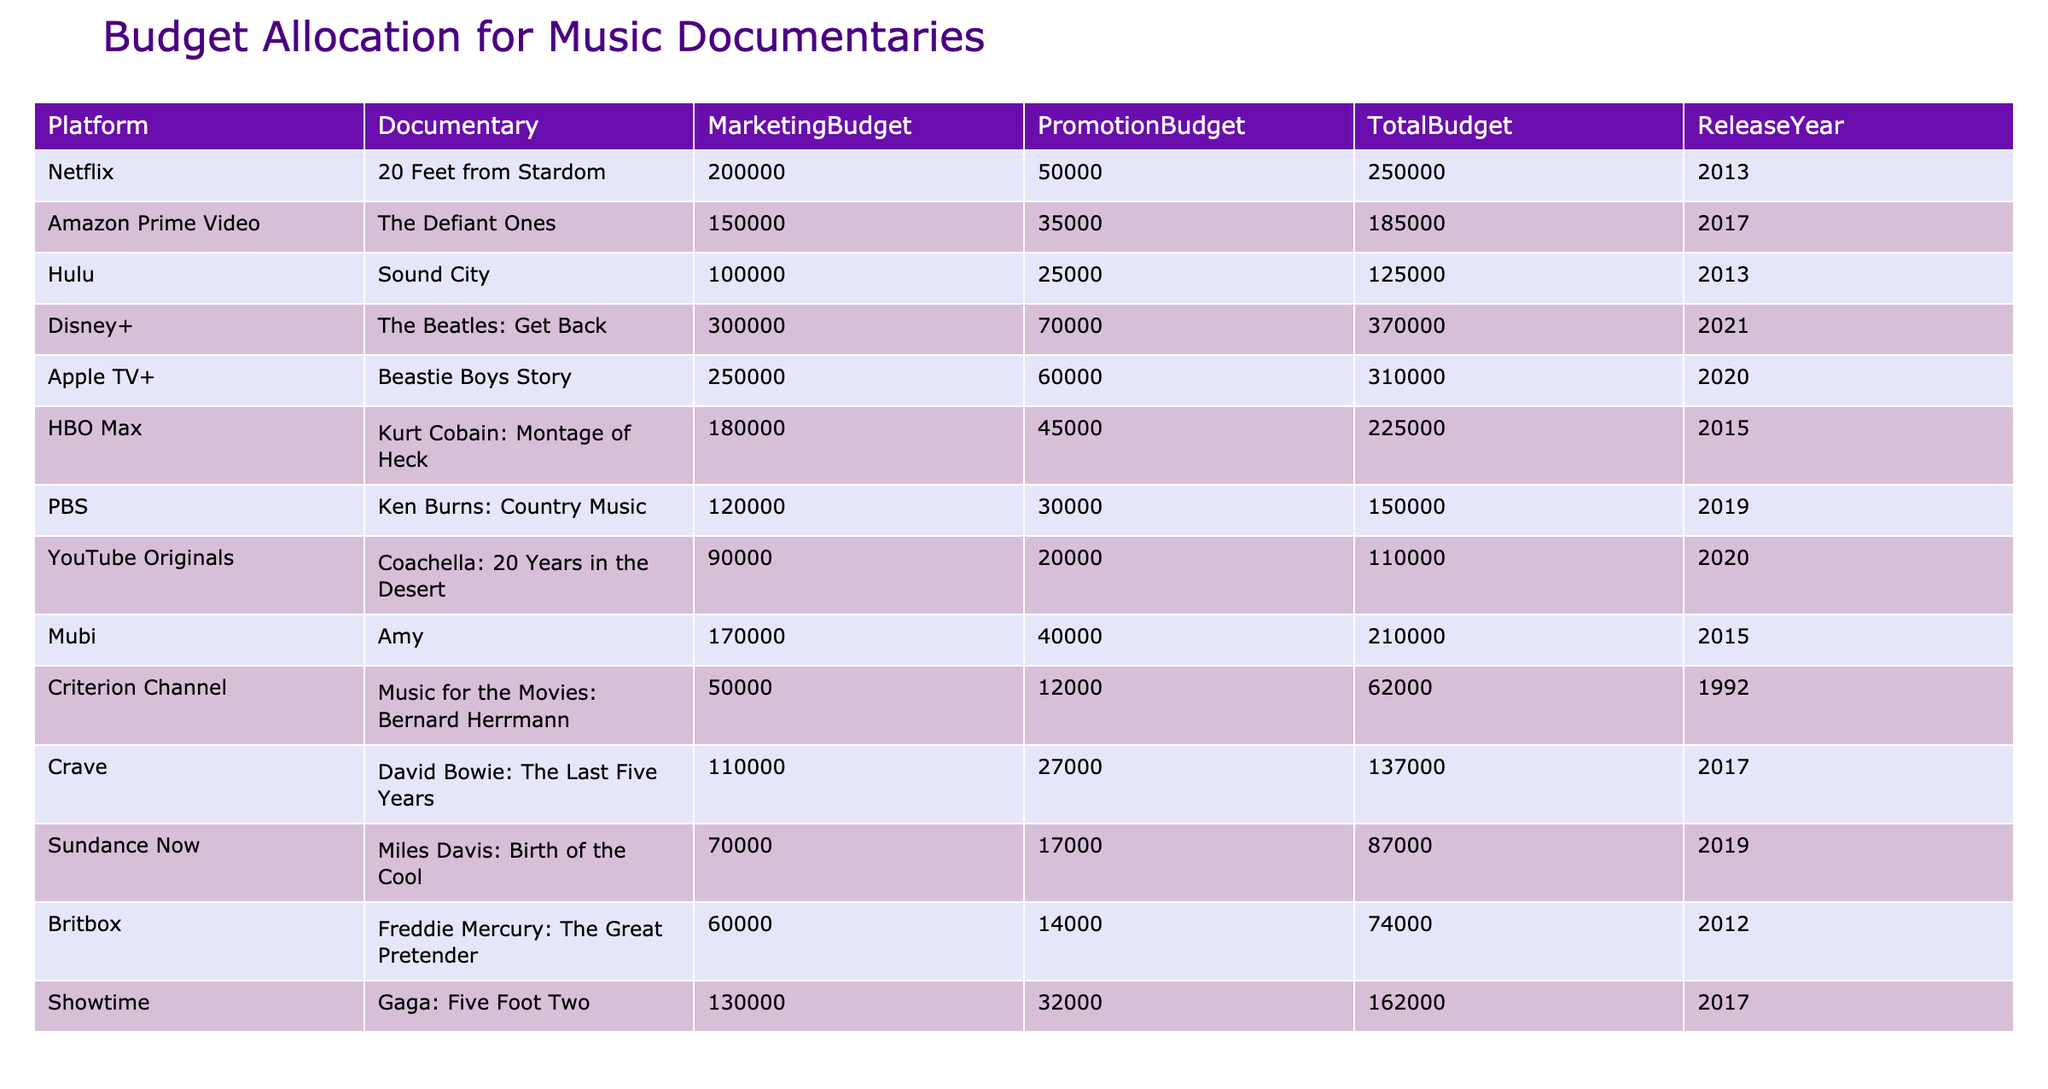What is the highest marketing budget allocated to a music documentary? The highest marketing budget can be found by reviewing the 'MarketingBudget' column. The largest value in that column is 300000, attributed to the documentary "The Beatles: Get Back" on Disney+.
Answer: 300000 Which platform has the lowest total budget for a music documentary? To find the lowest total budget, we look at the 'TotalBudget' column and find the smallest value, which is 62000 for "Music for the Movies: Bernard Herrmann" on Criterion Channel.
Answer: 62000 What is the combined total budget for documentaries released in 2017? We can sum the 'TotalBudget' values for documentaries released in 2017, which are "The Defiant Ones" (185000), "David Bowie: The Last Five Years" (137000), and "Gaga: Five Foot Two" (162000). The sum is 185000 + 137000 + 162000 = 484000.
Answer: 484000 Does Amazon Prime Video have a higher promotion budget than Hulu? By comparing the 'PromotionBudget' values, Amazon Prime Video has 35000 for "The Defiant Ones" and Hulu has 25000 for "Sound City". Since 35000 is greater than 25000, the statement is true.
Answer: Yes How much more is the total budget for "Beastie Boys Story" compared to "Sound City"? To compare, we examine 'TotalBudget' for "Beastie Boys Story" (310000) and "Sound City" (125000). The difference is calculated as 310000 - 125000 = 185000.
Answer: 185000 What percentage of the total budget for "Ken Burns: Country Music" is allocated to marketing? For "Ken Burns: Country Music", the total budget is 150000 and the marketing budget is 120000. To find the percentage, we use (120000 / 150000) * 100 = 80%.
Answer: 80% Which documentary had a total budget of 225000, and what platform was it on? Looking for the total budget of 225000, we find it for "Kurt Cobain: Montage of Heck" on HBO Max. This can be identified directly in the 'TotalBudget' column.
Answer: Kurt Cobain: Montage of Heck, HBO Max How many documentaries have a marketing budget of 100000 or more? The marketing budgets of 100000 or more include "20 Feet from Stardom", "The Defiant Ones", "Beastie Boys Story", "Kurt Cobain: Montage of Heck", and "Gaga: Five Foot Two". This totals to 5 documentaries.
Answer: 5 